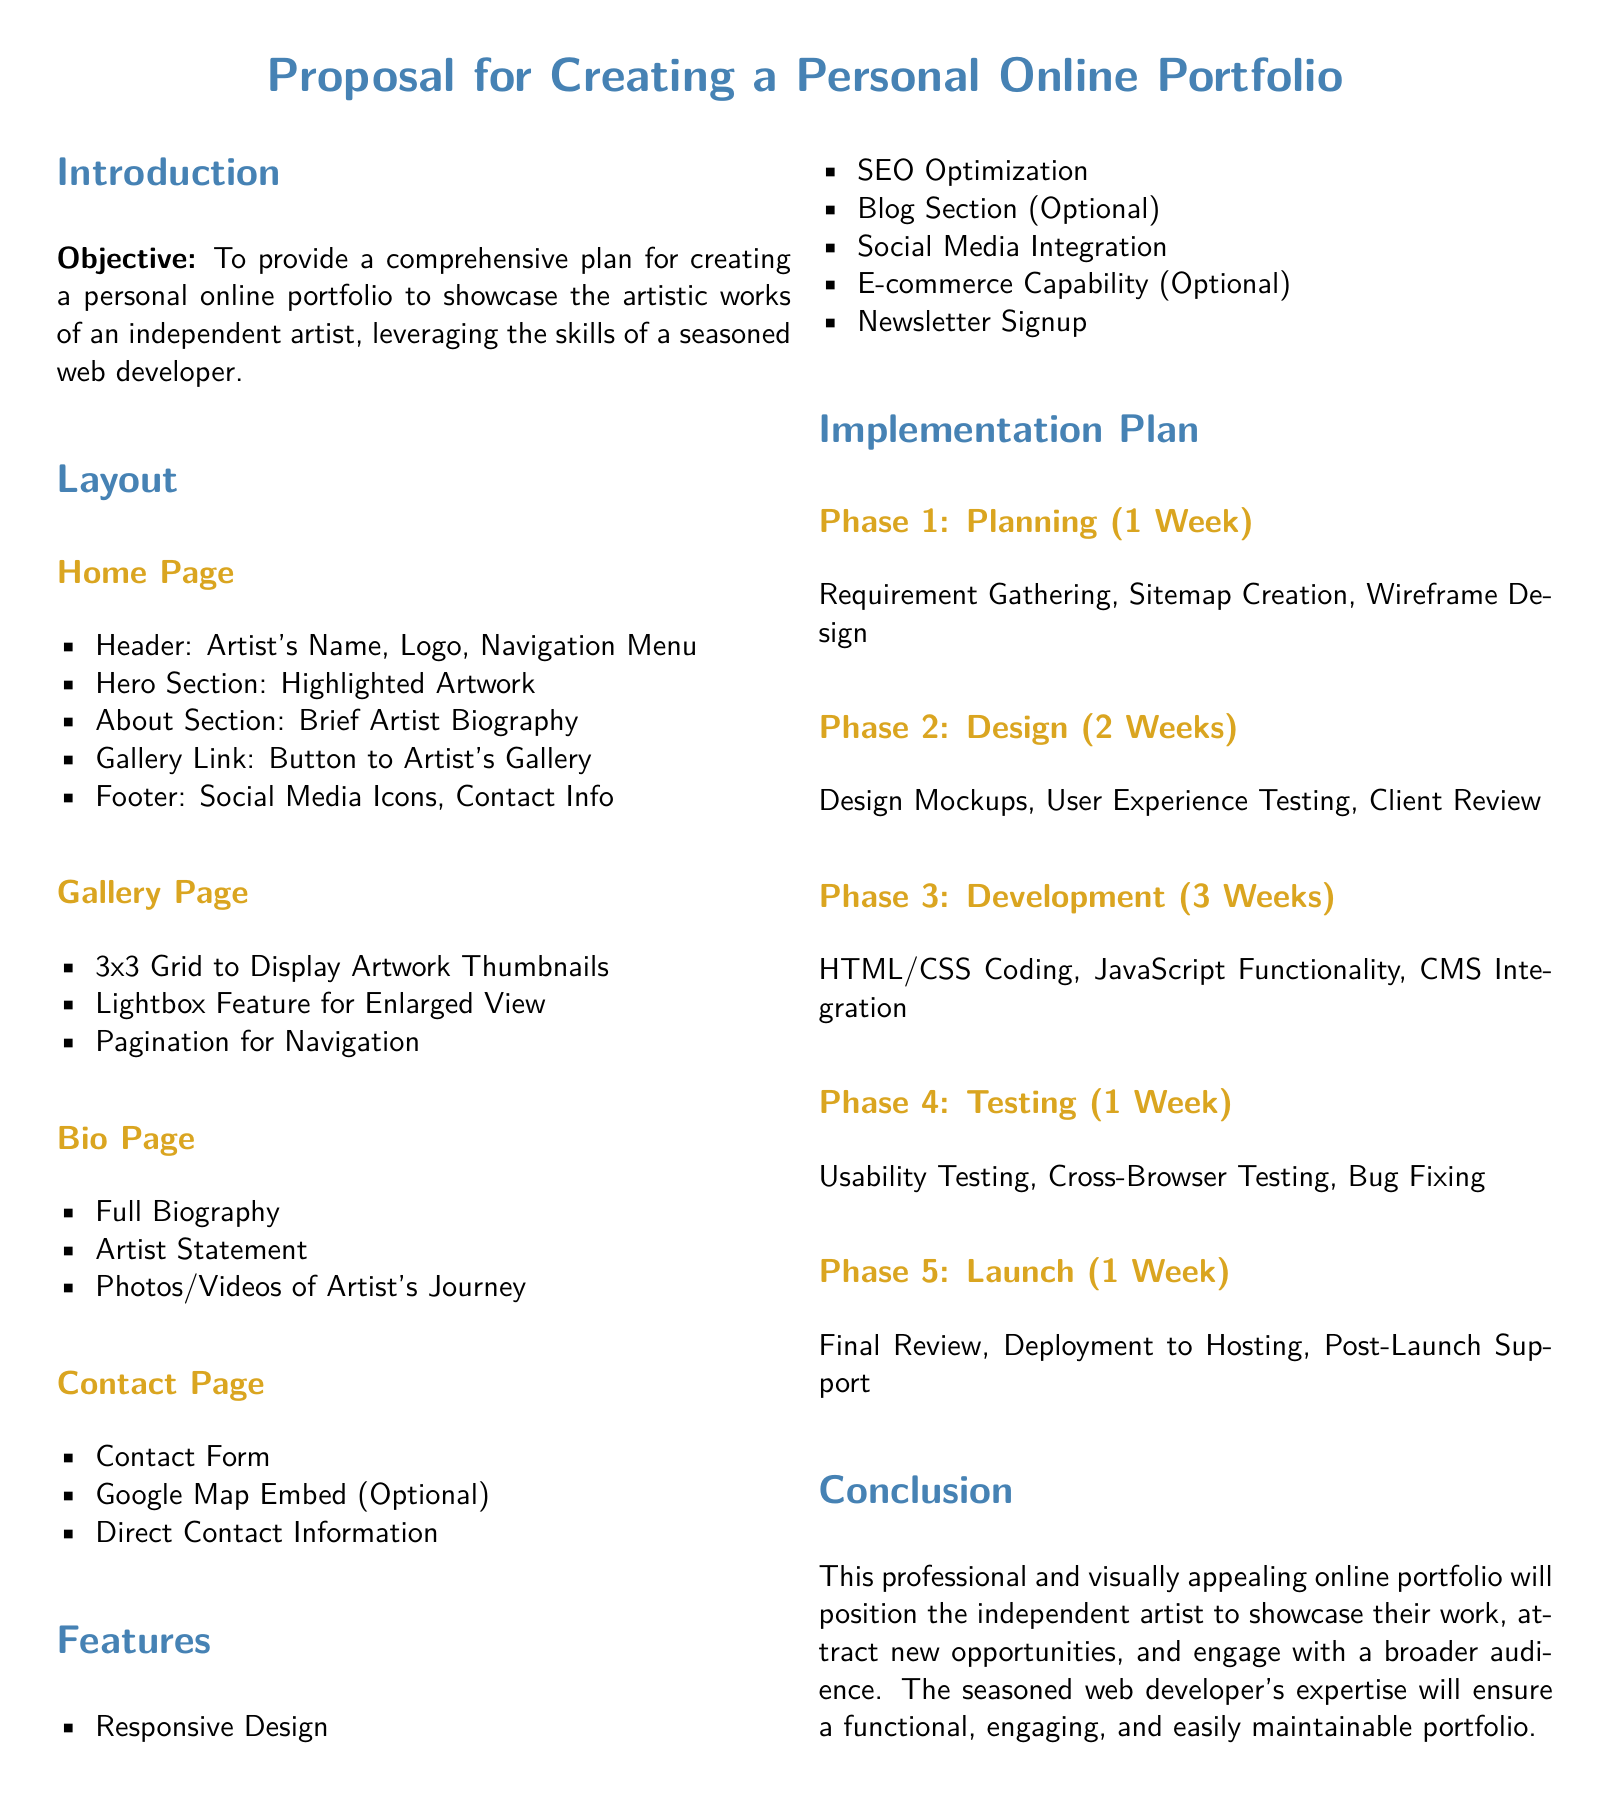What is the objective of the proposal? The objective is to provide a comprehensive plan for creating a personal online portfolio to showcase the artistic works of an independent artist.
Answer: Comprehensive plan for creating a personal online portfolio How long is the planning phase? The planning phase is specified in the implementation plan section of the document.
Answer: 1 Week What is included in the home page layout? The home page layout outlines specific sections, such as Header, Hero Section, About Section, Gallery Link, and Footer.
Answer: Header, Hero Section, About Section, Gallery Link, Footer How many weeks are allocated for the design phase? The design phase duration is denoted in the implementation plan.
Answer: 2 Weeks What feature is optional according to the proposal? The proposal specifies features that may or may not be included, referring to the e-commerce functionality as optional.
Answer: E-commerce Capability What element is used for enlarged view on the gallery page? The document describes a specific feature for displaying artwork which allows for enlarged viewing.
Answer: Lightbox Feature What will be tested during the testing phase? The testing phase involves usability testing, cross-browser testing, and bug fixing as detailed in the implementation plan.
Answer: Usability Testing, Cross-Browser Testing, Bug Fixing What is the color theme for the document's headings? The color theme for headings is specified through defined colors in the document.
Answer: Artist Blue and Artist Gold What type of design is emphasized in the features section? The features section highlights a specific design strategy important for user accessibility.
Answer: Responsive Design 